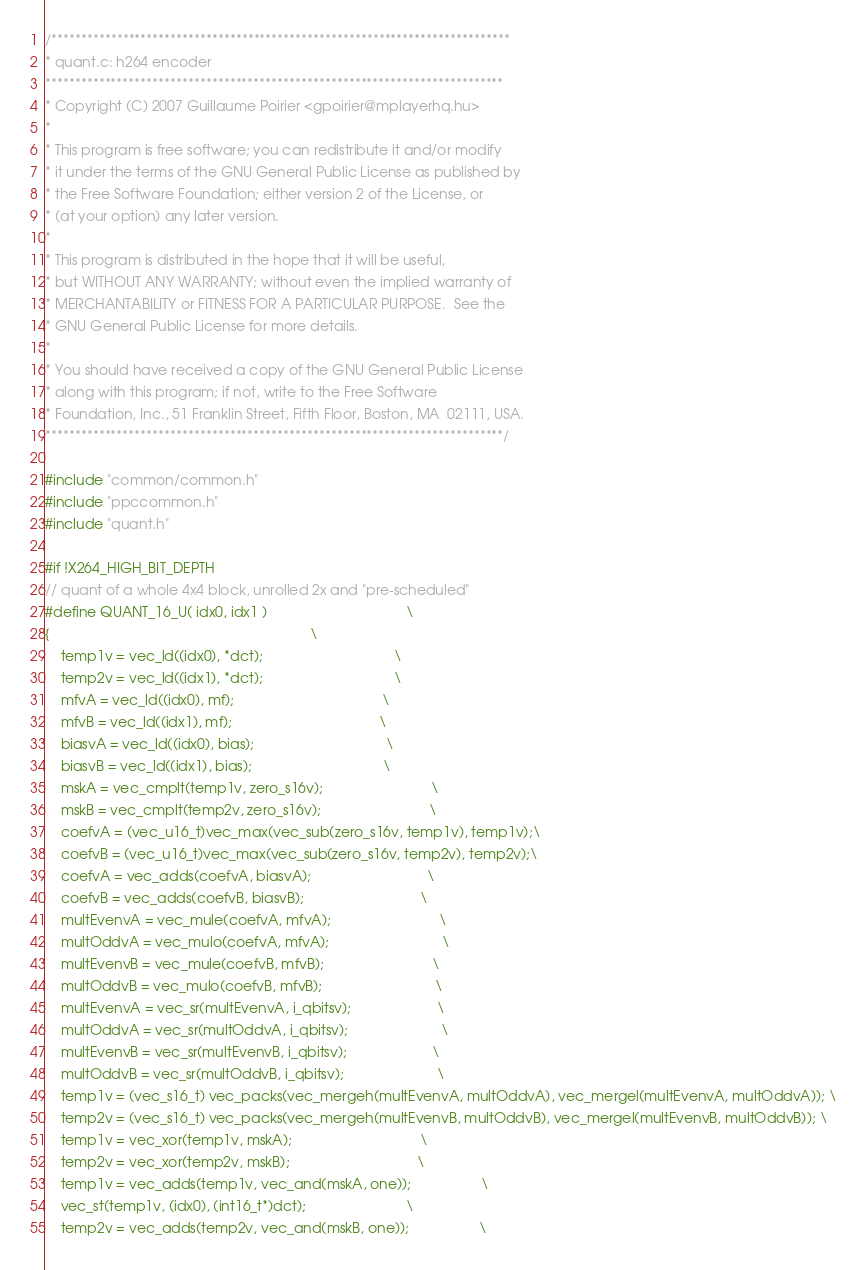Convert code to text. <code><loc_0><loc_0><loc_500><loc_500><_C_>/*****************************************************************************
* quant.c: h264 encoder
*****************************************************************************
* Copyright (C) 2007 Guillaume Poirier <gpoirier@mplayerhq.hu>
*
* This program is free software; you can redistribute it and/or modify
* it under the terms of the GNU General Public License as published by
* the Free Software Foundation; either version 2 of the License, or
* (at your option) any later version.
*
* This program is distributed in the hope that it will be useful,
* but WITHOUT ANY WARRANTY; without even the implied warranty of
* MERCHANTABILITY or FITNESS FOR A PARTICULAR PURPOSE.  See the
* GNU General Public License for more details.
*
* You should have received a copy of the GNU General Public License
* along with this program; if not, write to the Free Software
* Foundation, Inc., 51 Franklin Street, Fifth Floor, Boston, MA  02111, USA.
*****************************************************************************/

#include "common/common.h"
#include "ppccommon.h"
#include "quant.h"

#if !X264_HIGH_BIT_DEPTH
// quant of a whole 4x4 block, unrolled 2x and "pre-scheduled"
#define QUANT_16_U( idx0, idx1 )                                    \
{                                                                   \
    temp1v = vec_ld((idx0), *dct);                                  \
    temp2v = vec_ld((idx1), *dct);                                  \
    mfvA = vec_ld((idx0), mf);                                      \
    mfvB = vec_ld((idx1), mf);                                      \
    biasvA = vec_ld((idx0), bias);                                  \
    biasvB = vec_ld((idx1), bias);                                  \
    mskA = vec_cmplt(temp1v, zero_s16v);                            \
    mskB = vec_cmplt(temp2v, zero_s16v);                            \
    coefvA = (vec_u16_t)vec_max(vec_sub(zero_s16v, temp1v), temp1v);\
    coefvB = (vec_u16_t)vec_max(vec_sub(zero_s16v, temp2v), temp2v);\
    coefvA = vec_adds(coefvA, biasvA);                              \
    coefvB = vec_adds(coefvB, biasvB);                              \
    multEvenvA = vec_mule(coefvA, mfvA);                            \
    multOddvA = vec_mulo(coefvA, mfvA);                             \
    multEvenvB = vec_mule(coefvB, mfvB);                            \
    multOddvB = vec_mulo(coefvB, mfvB);                             \
    multEvenvA = vec_sr(multEvenvA, i_qbitsv);                      \
    multOddvA = vec_sr(multOddvA, i_qbitsv);                        \
    multEvenvB = vec_sr(multEvenvB, i_qbitsv);                      \
    multOddvB = vec_sr(multOddvB, i_qbitsv);                        \
    temp1v = (vec_s16_t) vec_packs(vec_mergeh(multEvenvA, multOddvA), vec_mergel(multEvenvA, multOddvA)); \
    temp2v = (vec_s16_t) vec_packs(vec_mergeh(multEvenvB, multOddvB), vec_mergel(multEvenvB, multOddvB)); \
    temp1v = vec_xor(temp1v, mskA);                                 \
    temp2v = vec_xor(temp2v, mskB);                                 \
    temp1v = vec_adds(temp1v, vec_and(mskA, one));                  \
    vec_st(temp1v, (idx0), (int16_t*)dct);                          \
    temp2v = vec_adds(temp2v, vec_and(mskB, one));                  \</code> 